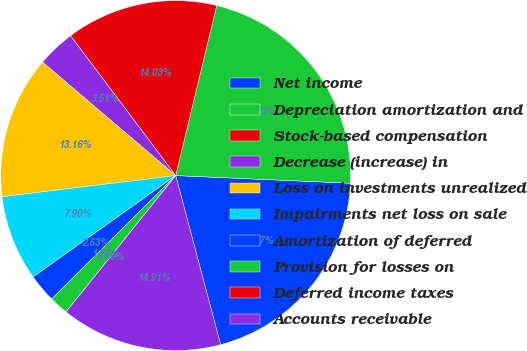<chart> <loc_0><loc_0><loc_500><loc_500><pie_chart><fcel>Net income<fcel>Depreciation amortization and<fcel>Stock-based compensation<fcel>Decrease (increase) in<fcel>Loss on investments unrealized<fcel>Impairments net loss on sale<fcel>Amortization of deferred<fcel>Provision for losses on<fcel>Deferred income taxes<fcel>Accounts receivable<nl><fcel>20.17%<fcel>21.93%<fcel>14.03%<fcel>3.51%<fcel>13.16%<fcel>7.9%<fcel>2.63%<fcel>1.76%<fcel>0.0%<fcel>14.91%<nl></chart> 